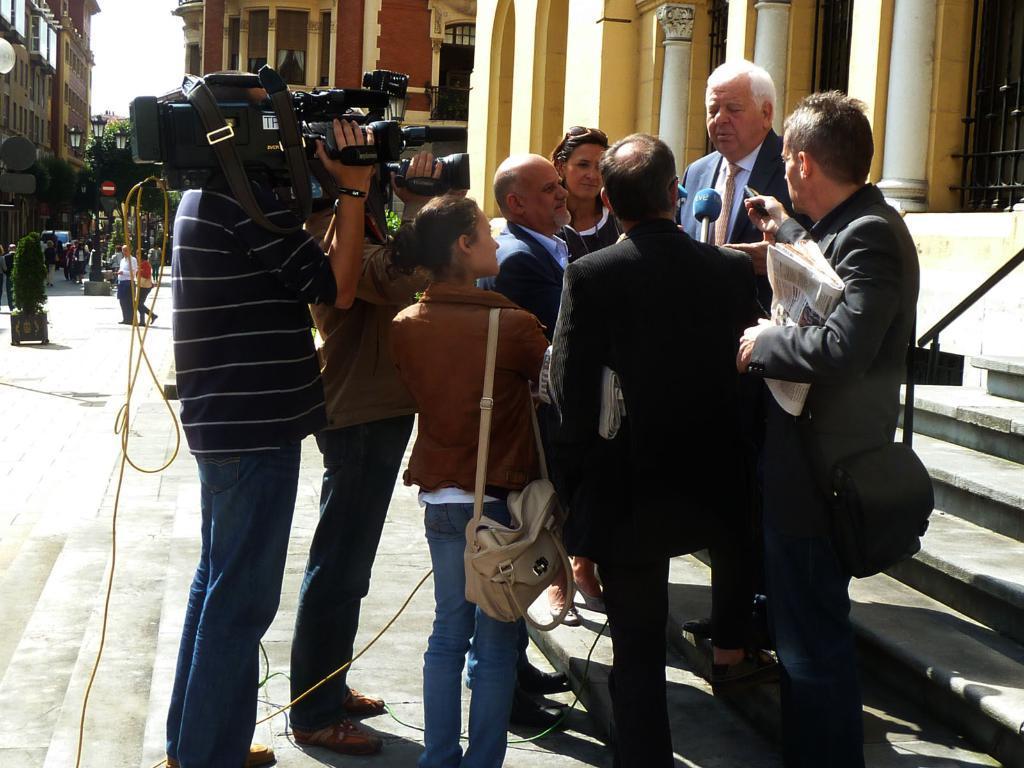In one or two sentences, can you explain what this image depicts? In this image, I can see a group of people standing. There are two persons holding video recorders. In the background, there is the sky, buildings, trees, a street light and groups of people on the road. 